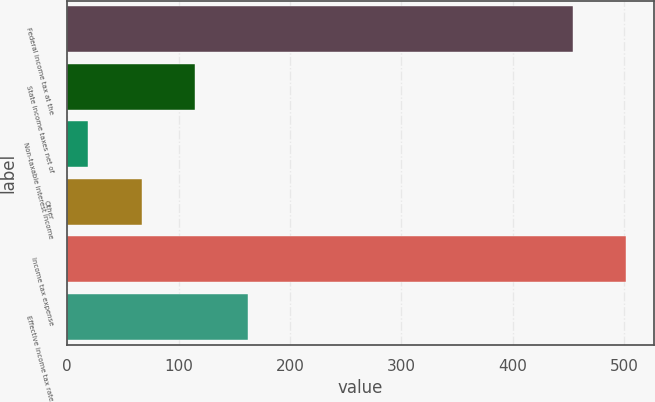Convert chart to OTSL. <chart><loc_0><loc_0><loc_500><loc_500><bar_chart><fcel>Federal income tax at the<fcel>State income taxes net of<fcel>Non-taxable interest income<fcel>Other<fcel>Income tax expense<fcel>Effective income tax rate<nl><fcel>454<fcel>114.4<fcel>19<fcel>66.7<fcel>501.7<fcel>162.1<nl></chart> 